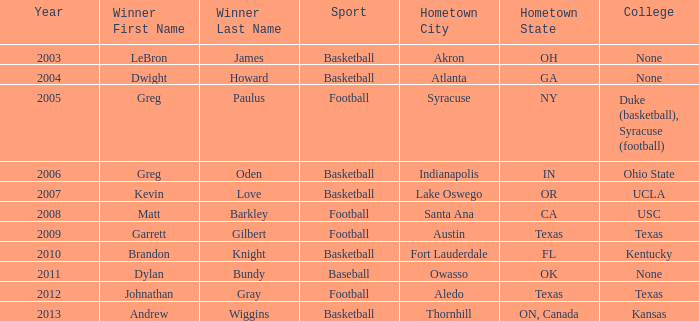What is Hometown, when Sport is "Basketball", and when Winner is "Dwight Howard"? Atlanta, GA. 